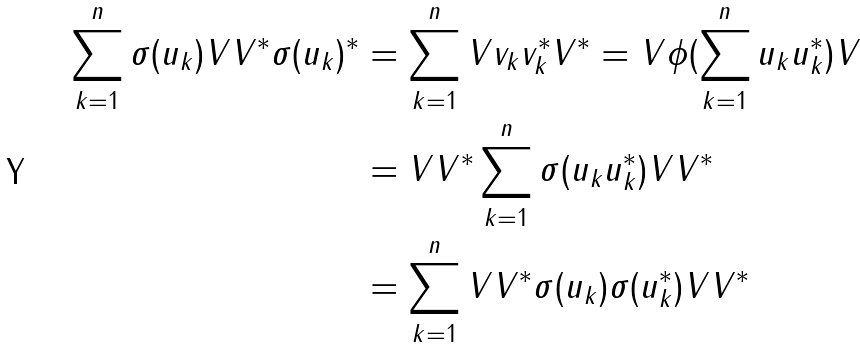Convert formula to latex. <formula><loc_0><loc_0><loc_500><loc_500>\sum _ { k = 1 } ^ { n } \sigma ( u _ { k } ) V V ^ { * } \sigma ( u _ { k } ) ^ { * } & = \sum _ { k = 1 } ^ { n } V v _ { k } v _ { k } ^ { * } V ^ { * } = V \phi ( \sum _ { k = 1 } ^ { n } u _ { k } u _ { k } ^ { * } ) V \\ & = V V ^ { * } \sum _ { k = 1 } ^ { n } \sigma ( u _ { k } u _ { k } ^ { * } ) V V ^ { * } \\ & = \sum _ { k = 1 } ^ { n } V V ^ { * } \sigma ( u _ { k } ) \sigma ( u _ { k } ^ { * } ) V V ^ { * }</formula> 